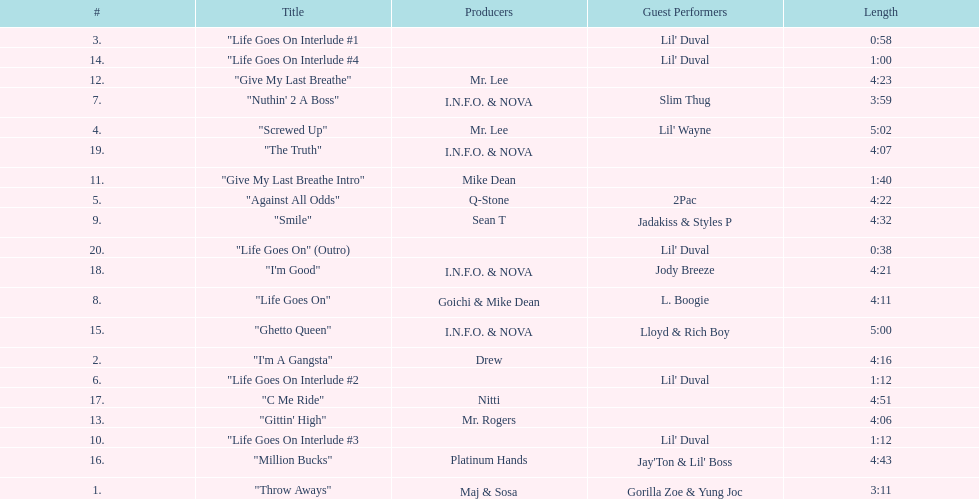Which producers produced the majority of songs on this record? I.N.F.O. & NOVA. 